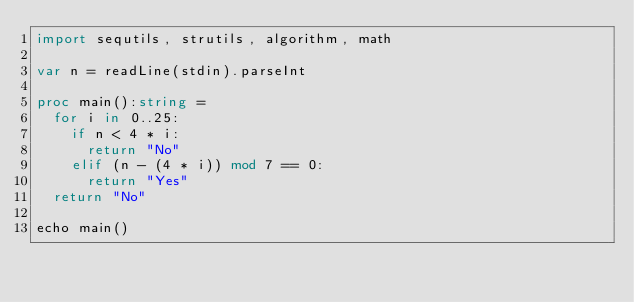Convert code to text. <code><loc_0><loc_0><loc_500><loc_500><_Nim_>import sequtils, strutils, algorithm, math

var n = readLine(stdin).parseInt

proc main():string =
  for i in 0..25:
    if n < 4 * i:
      return "No"
    elif (n - (4 * i)) mod 7 == 0:
      return "Yes"
  return "No"

echo main()</code> 